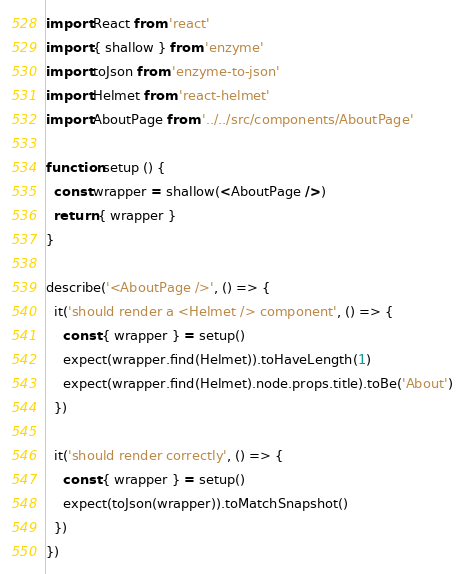<code> <loc_0><loc_0><loc_500><loc_500><_JavaScript_>import React from 'react'
import { shallow } from 'enzyme'
import toJson from 'enzyme-to-json'
import Helmet from 'react-helmet'
import AboutPage from '../../src/components/AboutPage'

function setup () {
  const wrapper = shallow(<AboutPage />)
  return { wrapper }
}

describe('<AboutPage />', () => {
  it('should render a <Helmet /> component', () => {
    const { wrapper } = setup()
    expect(wrapper.find(Helmet)).toHaveLength(1)
    expect(wrapper.find(Helmet).node.props.title).toBe('About')
  })

  it('should render correctly', () => {
    const { wrapper } = setup()
    expect(toJson(wrapper)).toMatchSnapshot()
  })
})
</code> 